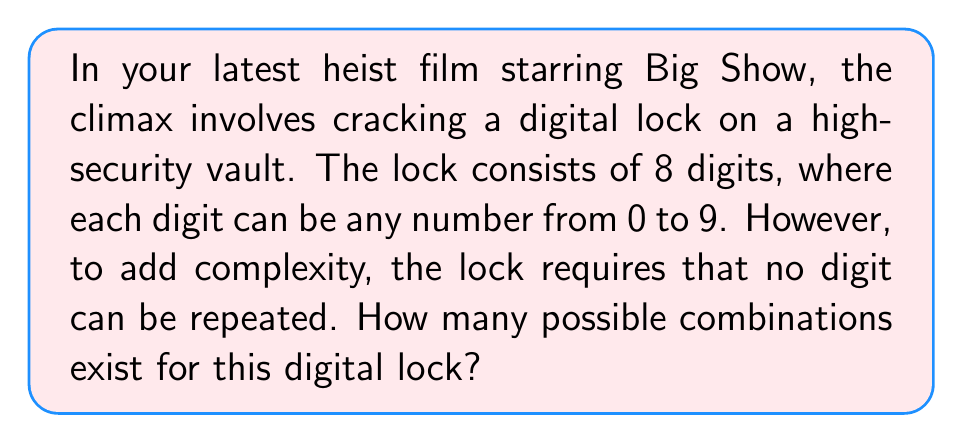What is the answer to this math problem? Let's approach this step-by-step:

1) We are dealing with a permutation problem, as the order of digits matters.

2) We have 10 possible digits (0-9) to choose from for the first position.

3) For the second position, we have 9 choices left, as we can't repeat the first digit.

4) For the third position, we have 8 choices, and so on.

5) This continues until we've filled all 8 positions.

6) Mathematically, this is represented by the permutation formula:

   $$P(10,8) = 10 \times 9 \times 8 \times 7 \times 6 \times 5 \times 4 \times 3$$

7) We can simplify this as:

   $$\frac{10!}{(10-8)!} = \frac{10!}{2!}$$

8) Calculating this:
   
   $$\frac{10 \times 9 \times 8 \times 7 \times 6 \times 5 \times 4 \times 3 \times 2 \times 1}{2 \times 1} = 1,814,400$$

Therefore, there are 1,814,400 possible combinations for the digital lock.
Answer: 1,814,400 